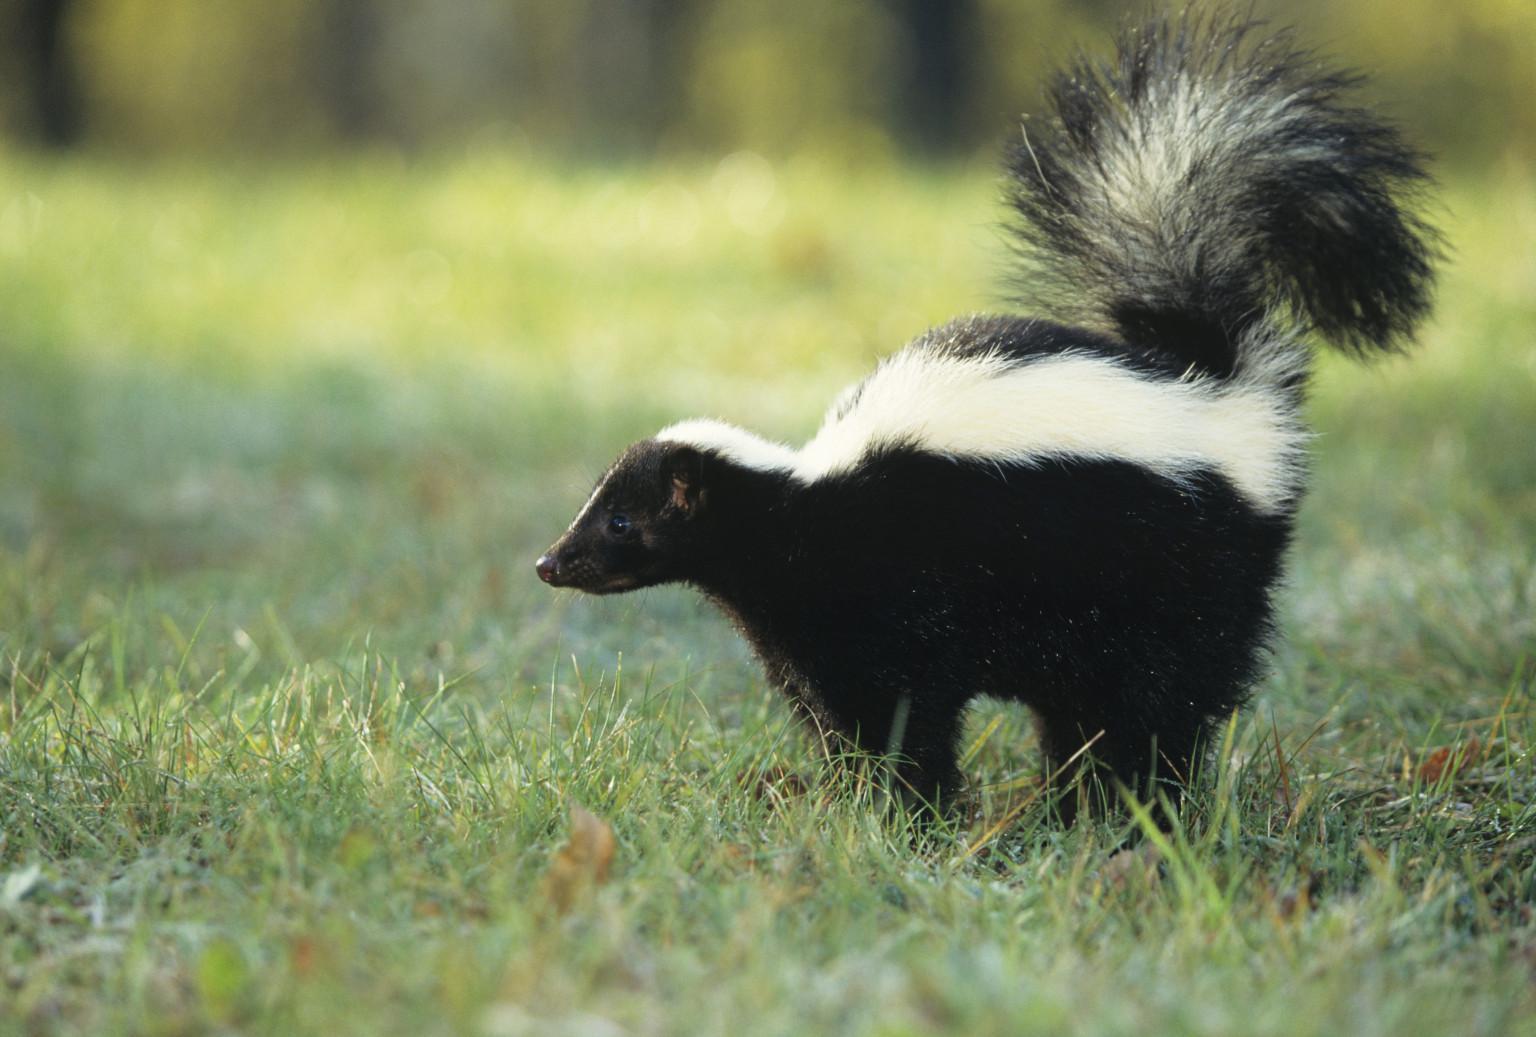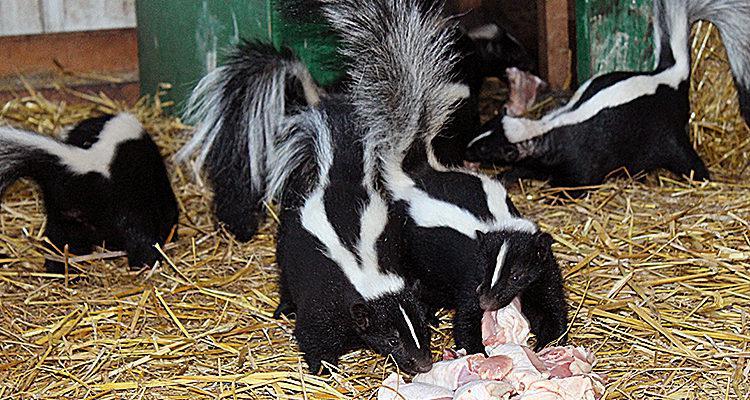The first image is the image on the left, the second image is the image on the right. For the images displayed, is the sentence "There is one skunk in one image, and more than one skunk in the other image." factually correct? Answer yes or no. Yes. The first image is the image on the left, the second image is the image on the right. Evaluate the accuracy of this statement regarding the images: "There are exactly two skunks.". Is it true? Answer yes or no. No. 